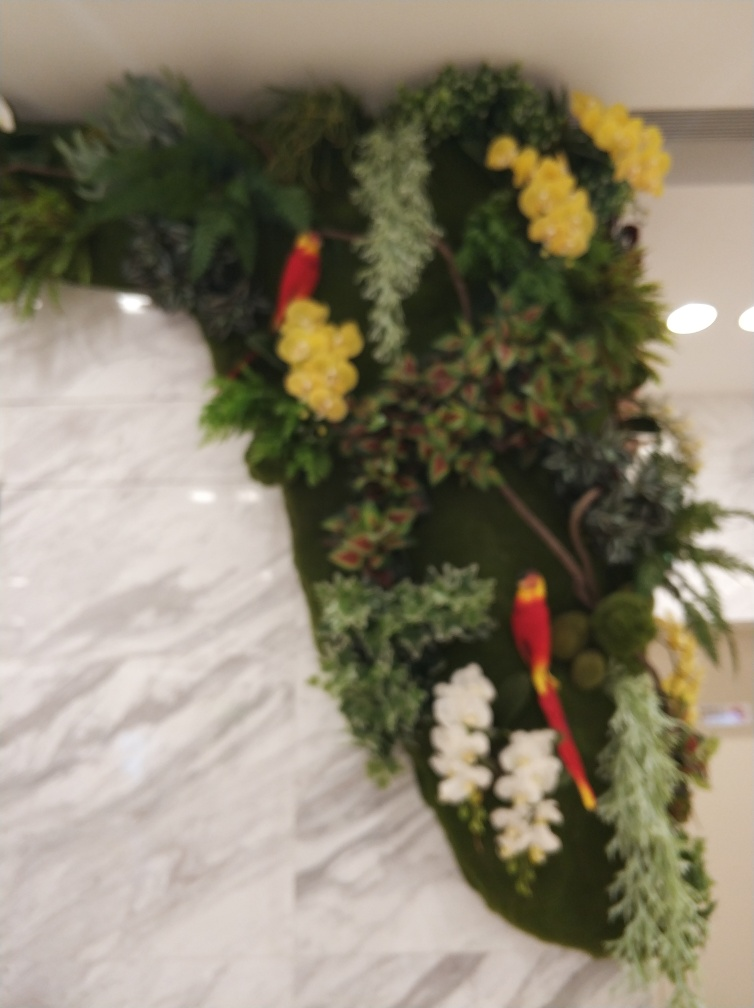What colors can be seen on the bird in the image? The bird in the image predominantly features a bright red color with some yellow accents visible. Despite the slight blur, these colors stand out against the green foliage. 